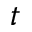Convert formula to latex. <formula><loc_0><loc_0><loc_500><loc_500>t</formula> 